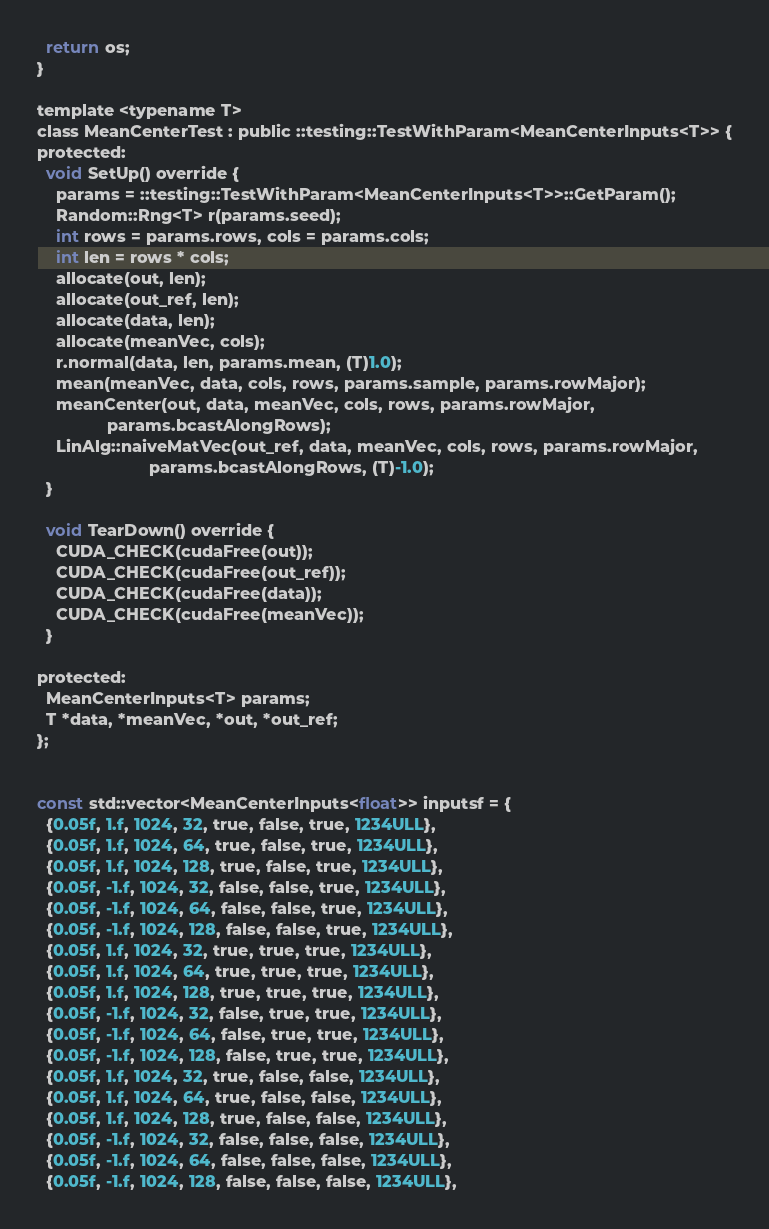Convert code to text. <code><loc_0><loc_0><loc_500><loc_500><_Cuda_>  return os;
}

template <typename T>
class MeanCenterTest : public ::testing::TestWithParam<MeanCenterInputs<T>> {
protected:
  void SetUp() override {
    params = ::testing::TestWithParam<MeanCenterInputs<T>>::GetParam();
    Random::Rng<T> r(params.seed);
    int rows = params.rows, cols = params.cols;
    int len = rows * cols;
    allocate(out, len);
    allocate(out_ref, len);
    allocate(data, len);
    allocate(meanVec, cols);
    r.normal(data, len, params.mean, (T)1.0);
    mean(meanVec, data, cols, rows, params.sample, params.rowMajor);
    meanCenter(out, data, meanVec, cols, rows, params.rowMajor,
               params.bcastAlongRows);
    LinAlg::naiveMatVec(out_ref, data, meanVec, cols, rows, params.rowMajor,
                        params.bcastAlongRows, (T)-1.0);
  }

  void TearDown() override {
    CUDA_CHECK(cudaFree(out));
    CUDA_CHECK(cudaFree(out_ref));
    CUDA_CHECK(cudaFree(data));
    CUDA_CHECK(cudaFree(meanVec));
  }

protected:
  MeanCenterInputs<T> params;
  T *data, *meanVec, *out, *out_ref;
};


const std::vector<MeanCenterInputs<float>> inputsf = {
  {0.05f, 1.f, 1024, 32, true, false, true, 1234ULL},
  {0.05f, 1.f, 1024, 64, true, false, true, 1234ULL},
  {0.05f, 1.f, 1024, 128, true, false, true, 1234ULL},
  {0.05f, -1.f, 1024, 32, false, false, true, 1234ULL},
  {0.05f, -1.f, 1024, 64, false, false, true, 1234ULL},
  {0.05f, -1.f, 1024, 128, false, false, true, 1234ULL},
  {0.05f, 1.f, 1024, 32, true, true, true, 1234ULL},
  {0.05f, 1.f, 1024, 64, true, true, true, 1234ULL},
  {0.05f, 1.f, 1024, 128, true, true, true, 1234ULL},
  {0.05f, -1.f, 1024, 32, false, true, true, 1234ULL},
  {0.05f, -1.f, 1024, 64, false, true, true, 1234ULL},
  {0.05f, -1.f, 1024, 128, false, true, true, 1234ULL},
  {0.05f, 1.f, 1024, 32, true, false, false, 1234ULL},
  {0.05f, 1.f, 1024, 64, true, false, false, 1234ULL},
  {0.05f, 1.f, 1024, 128, true, false, false, 1234ULL},
  {0.05f, -1.f, 1024, 32, false, false, false, 1234ULL},
  {0.05f, -1.f, 1024, 64, false, false, false, 1234ULL},
  {0.05f, -1.f, 1024, 128, false, false, false, 1234ULL},</code> 